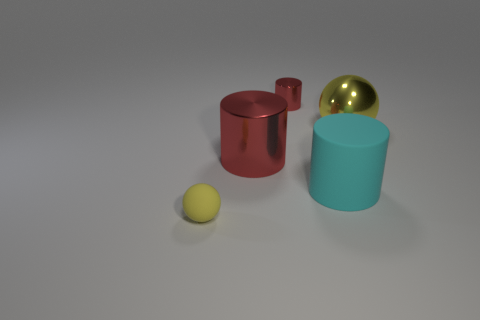Subtract all green balls. Subtract all blue cylinders. How many balls are left? 2 Add 1 objects. How many objects exist? 6 Subtract all spheres. How many objects are left? 3 Add 2 small cylinders. How many small cylinders exist? 3 Subtract 0 red cubes. How many objects are left? 5 Subtract all tiny red shiny things. Subtract all large shiny cylinders. How many objects are left? 3 Add 5 rubber objects. How many rubber objects are left? 7 